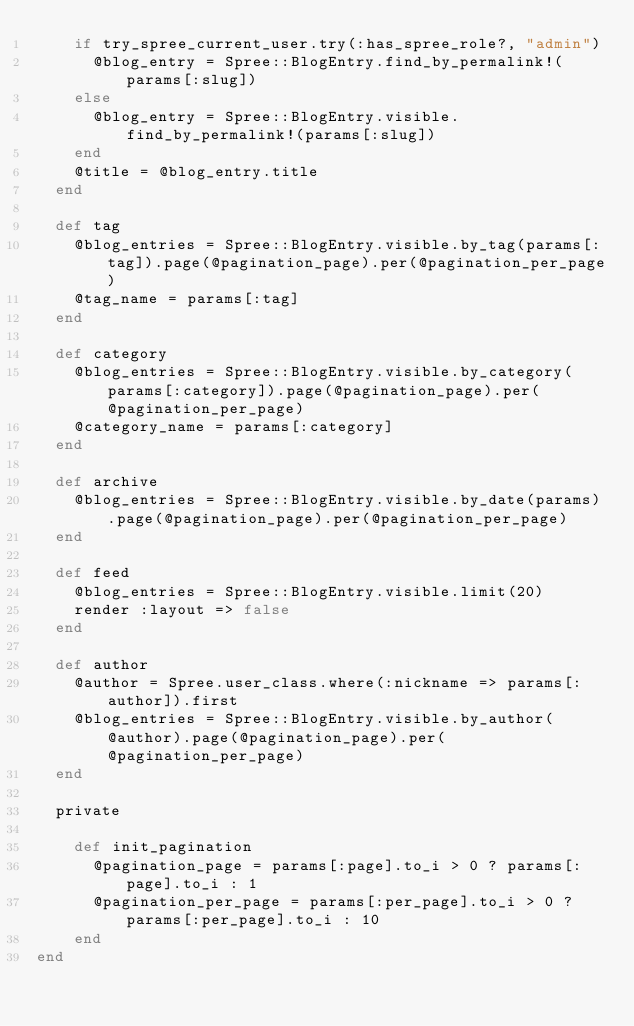Convert code to text. <code><loc_0><loc_0><loc_500><loc_500><_Ruby_>    if try_spree_current_user.try(:has_spree_role?, "admin")
      @blog_entry = Spree::BlogEntry.find_by_permalink!(params[:slug])
    else
      @blog_entry = Spree::BlogEntry.visible.find_by_permalink!(params[:slug])
    end
    @title = @blog_entry.title
  end

  def tag
    @blog_entries = Spree::BlogEntry.visible.by_tag(params[:tag]).page(@pagination_page).per(@pagination_per_page)
    @tag_name = params[:tag]
  end

  def category
    @blog_entries = Spree::BlogEntry.visible.by_category(params[:category]).page(@pagination_page).per(@pagination_per_page)
    @category_name = params[:category]
  end

  def archive
    @blog_entries = Spree::BlogEntry.visible.by_date(params).page(@pagination_page).per(@pagination_per_page)
  end

  def feed
    @blog_entries = Spree::BlogEntry.visible.limit(20)
    render :layout => false
  end

  def author
    @author = Spree.user_class.where(:nickname => params[:author]).first
    @blog_entries = Spree::BlogEntry.visible.by_author(@author).page(@pagination_page).per(@pagination_per_page)
  end

  private

    def init_pagination
      @pagination_page = params[:page].to_i > 0 ? params[:page].to_i : 1
      @pagination_per_page = params[:per_page].to_i > 0 ? params[:per_page].to_i : 10
    end
end
</code> 